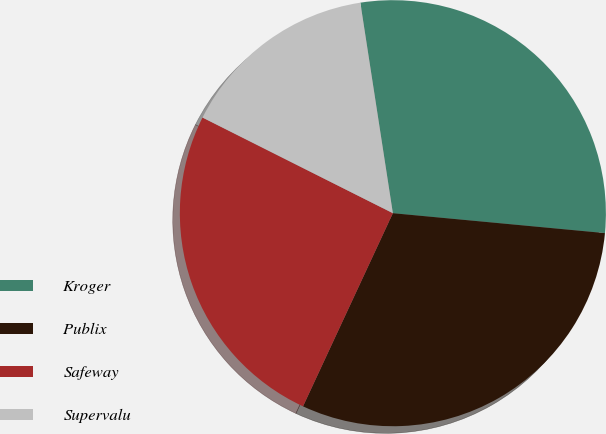Convert chart to OTSL. <chart><loc_0><loc_0><loc_500><loc_500><pie_chart><fcel>Kroger<fcel>Publix<fcel>Safeway<fcel>Supervalu<nl><fcel>28.93%<fcel>30.44%<fcel>25.48%<fcel>15.15%<nl></chart> 